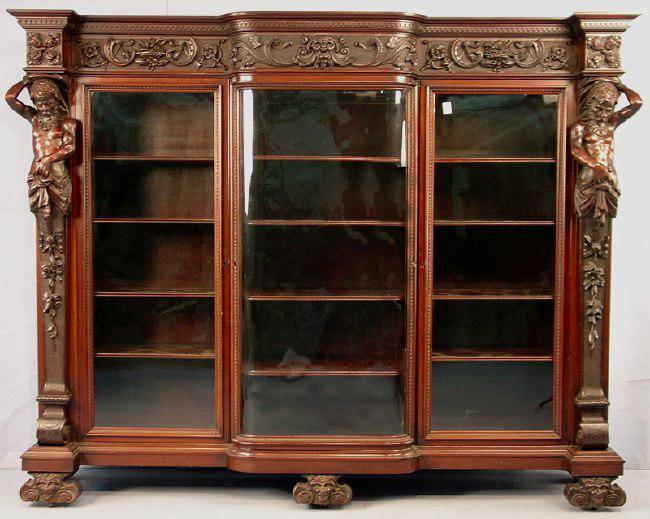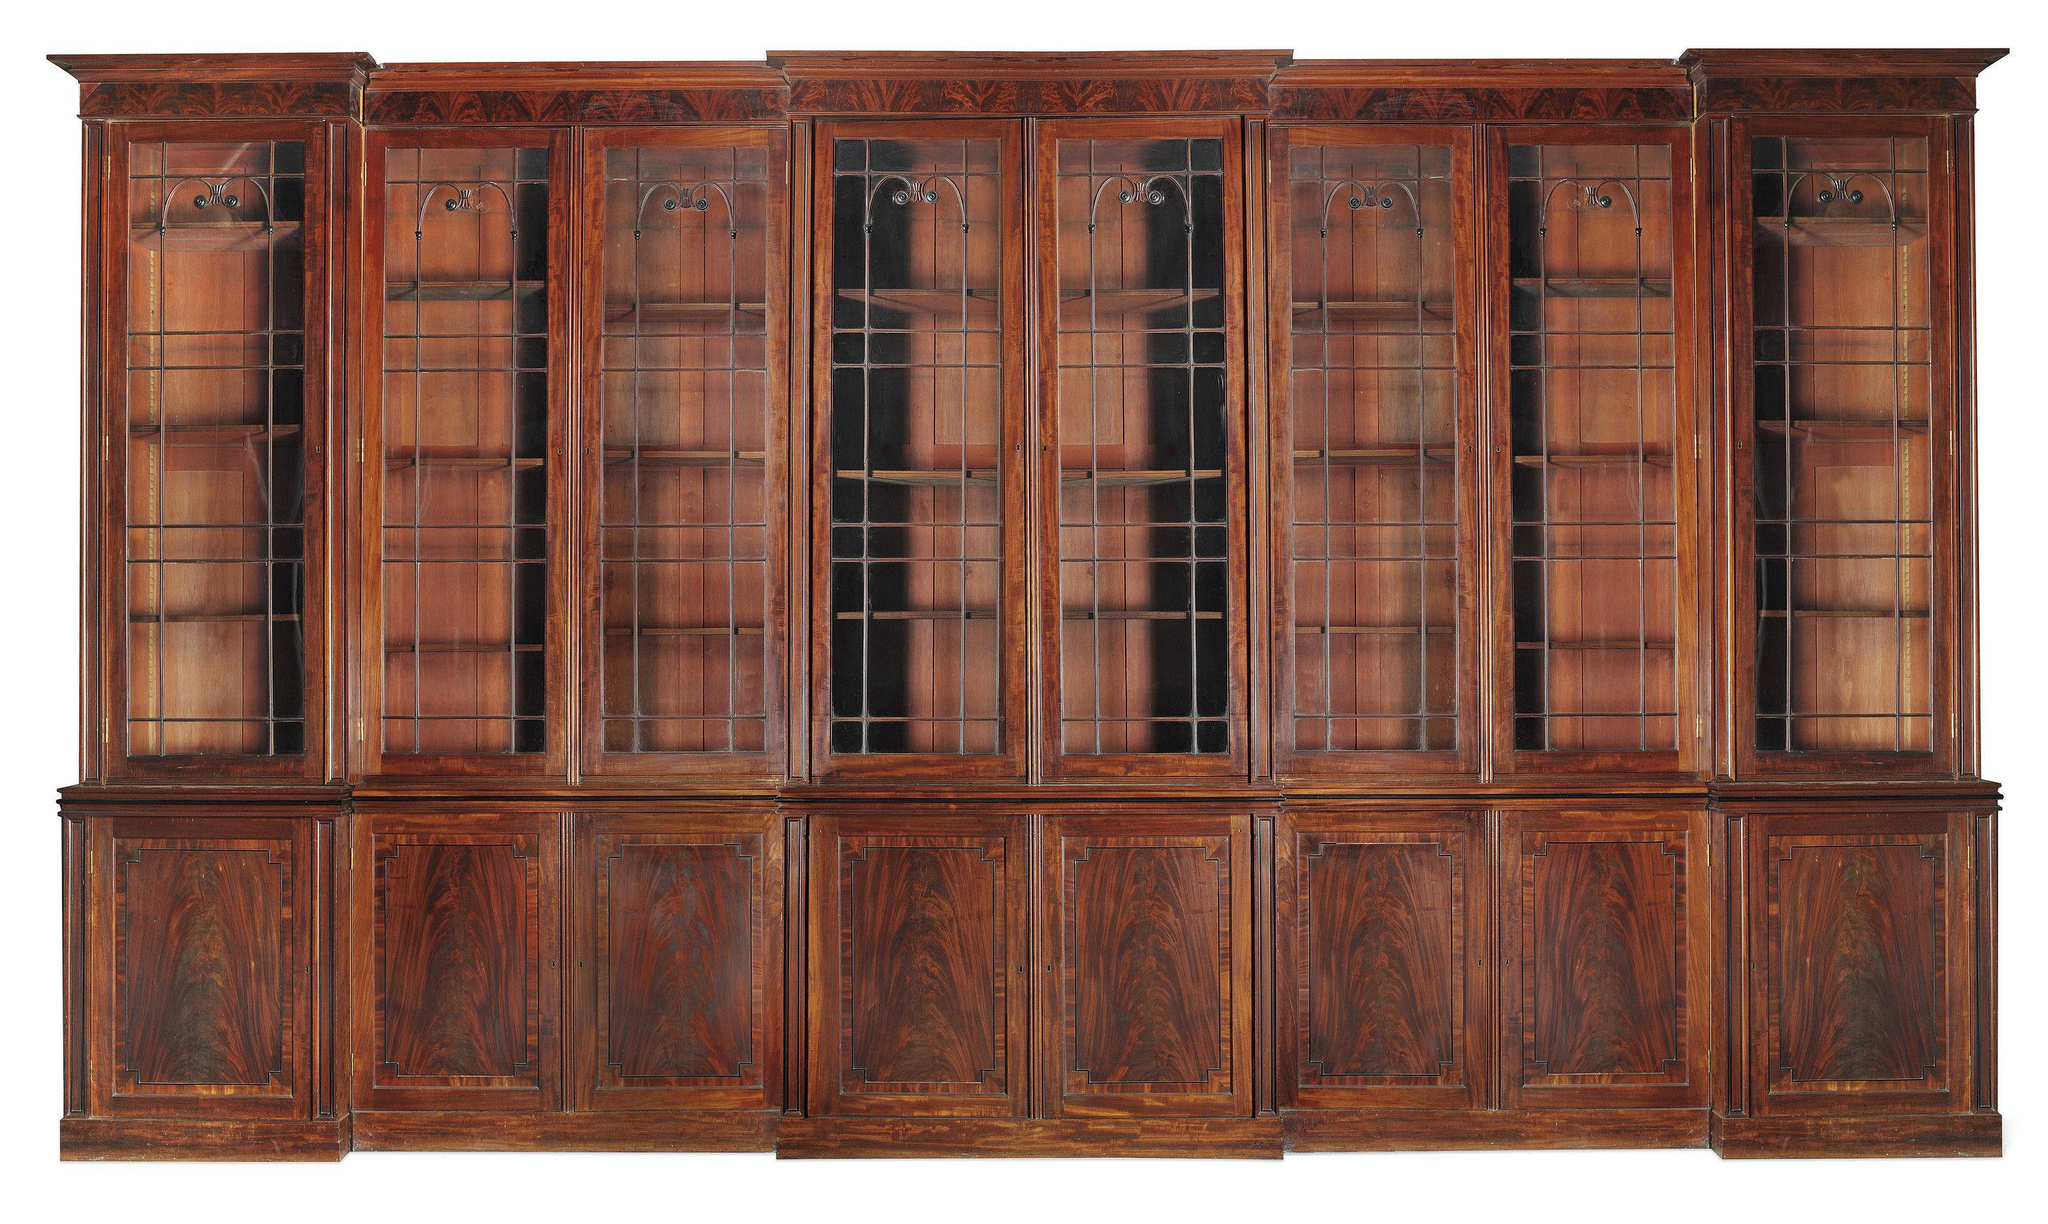The first image is the image on the left, the second image is the image on the right. Assess this claim about the two images: "In one of the images there is a bookshelf with books on it.". Correct or not? Answer yes or no. No. 